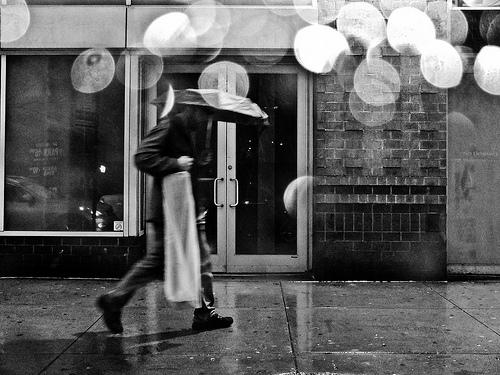Mention the most noticeable aspect of the image in a sentence. A man walks with an umbrella and bag on a wet sidewalk, with water droplets visible on the camera lens. Summarize the key elements of the image in a brief statement. Man with beard strolls on rainy sidewalk, umbrella in hand, and clutches a bag. Describe the weather condition and the main action of the person in the image. In a rainy scene, a man protects himself with an umbrella, while carrying a plastic bag and walking down a wet street. Mention the central figure and their activity in the image. A bearded individual holds an umbrella and a bag while traversing a rainy street. Identify the main character and their activity in the image, mentioning the weather condition. Under rainy conditions, a man with a beard uses an umbrella for shelter as he walks and carries a bag with him. Briefly narrate the central activity depicted in the image. A bearded man is walking on a wet sidewalk, holding an umbrella and a plastic bag. Characterize the dominant subject in the image and their current activity. Umbrella-toting bearded man walks down a damp street holding a plastic bag. Provide a vivid description of the primary subject and their actions in the image. A man with facial hair braves the rain, skillfully wielding a dark umbrella and grasping a bag while navigating the slick sidewalk. Write about the main character's appearance and activity in the image. A bearded man, wearing dark clothing, walks along a wet pavement holding an umbrella over his head and clutching a plastic bag. In a concise manner, state what the person in the image is doing and the environment. Bearded man walks in the rain, holding umbrella and bag on wet pavement. 